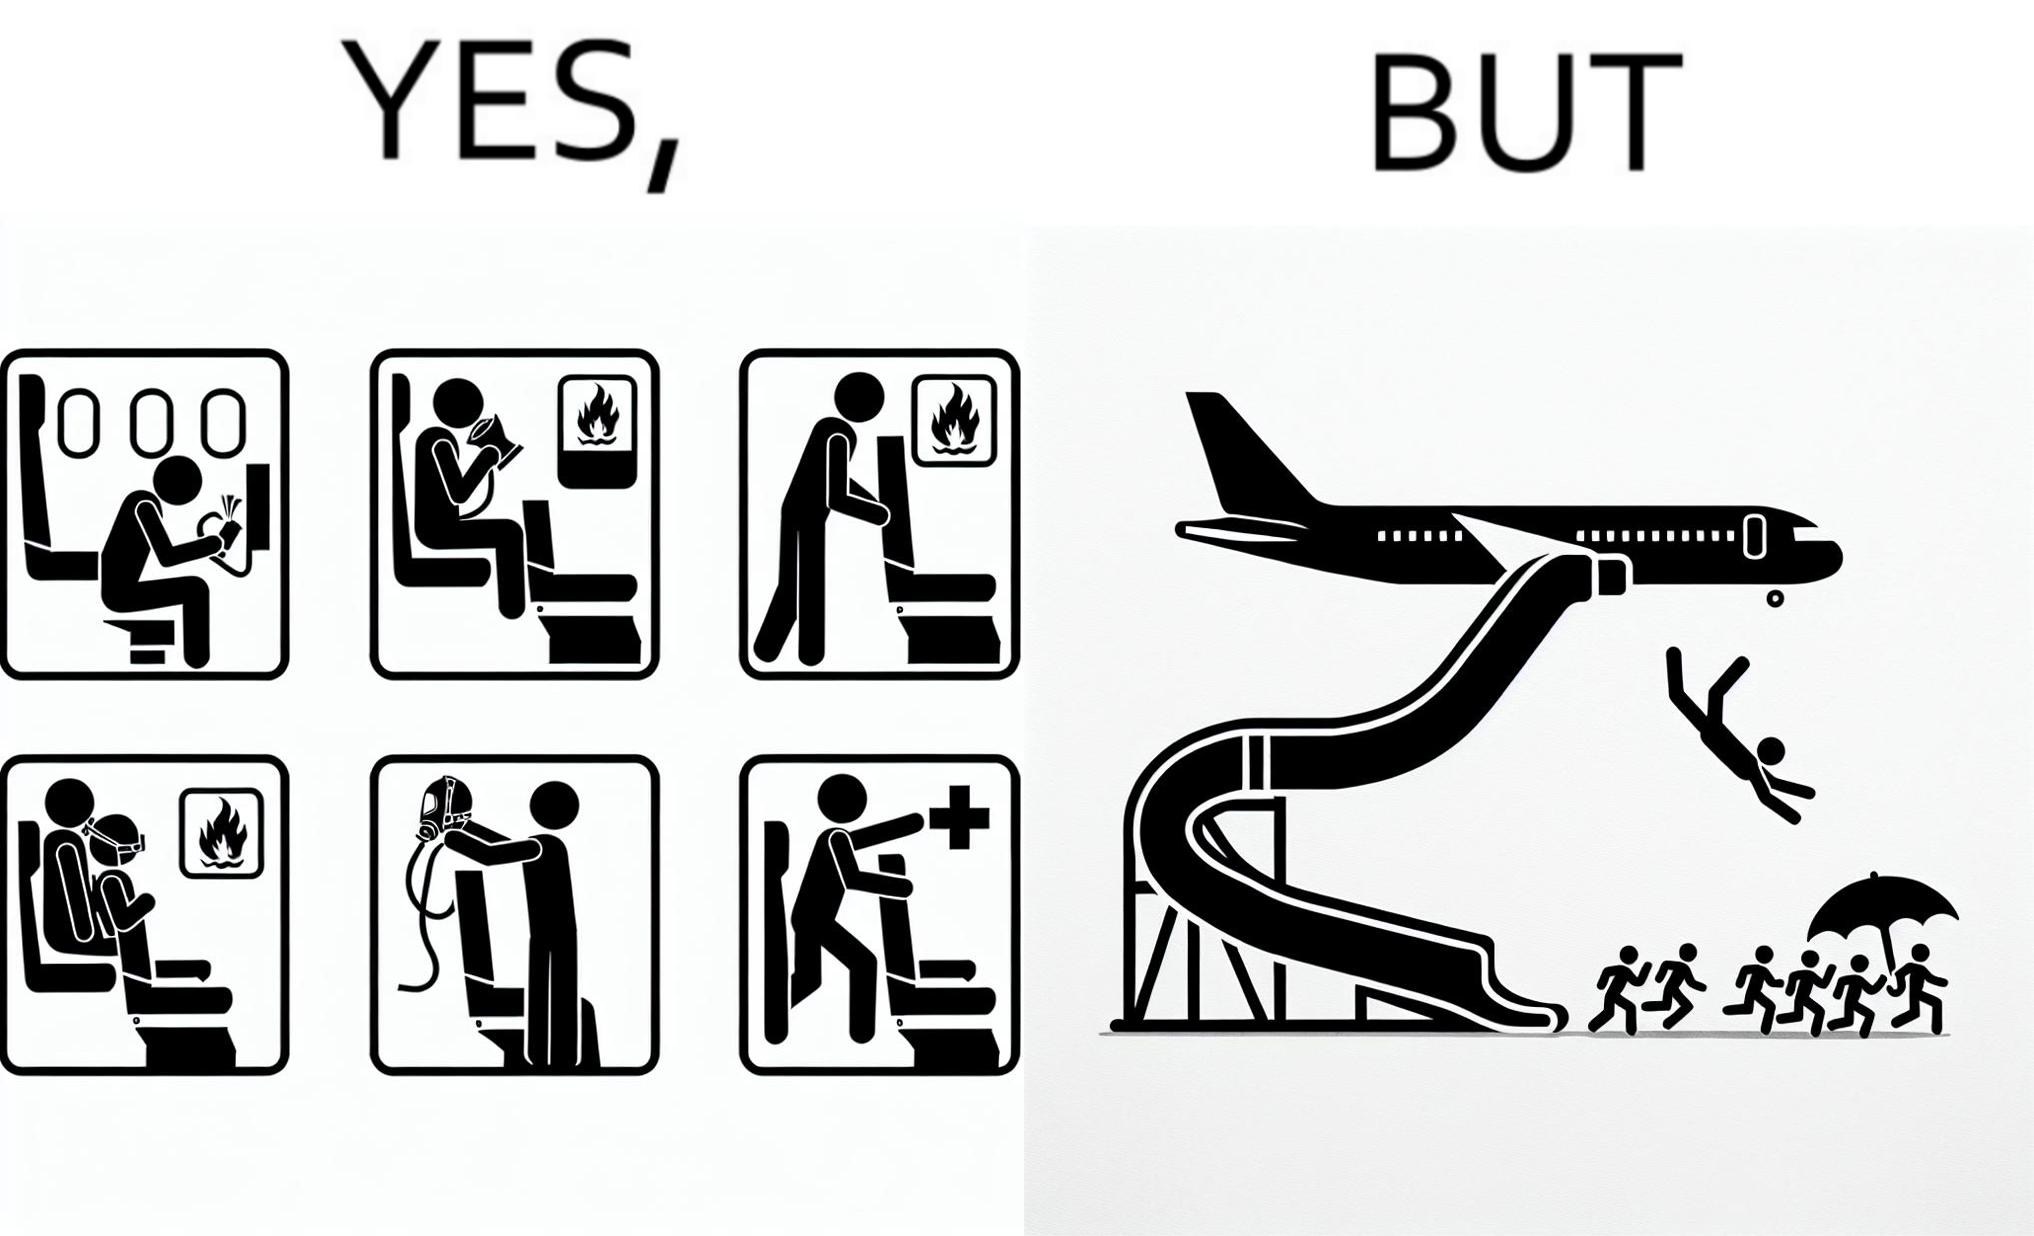Is this a satirical image? Yes, this image is satirical. 